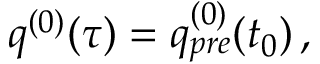Convert formula to latex. <formula><loc_0><loc_0><loc_500><loc_500>\begin{array} { r } { q ^ { ( 0 ) } ( \tau ) = q _ { p r e } ^ { ( 0 ) } ( t _ { 0 } ) \, , } \end{array}</formula> 